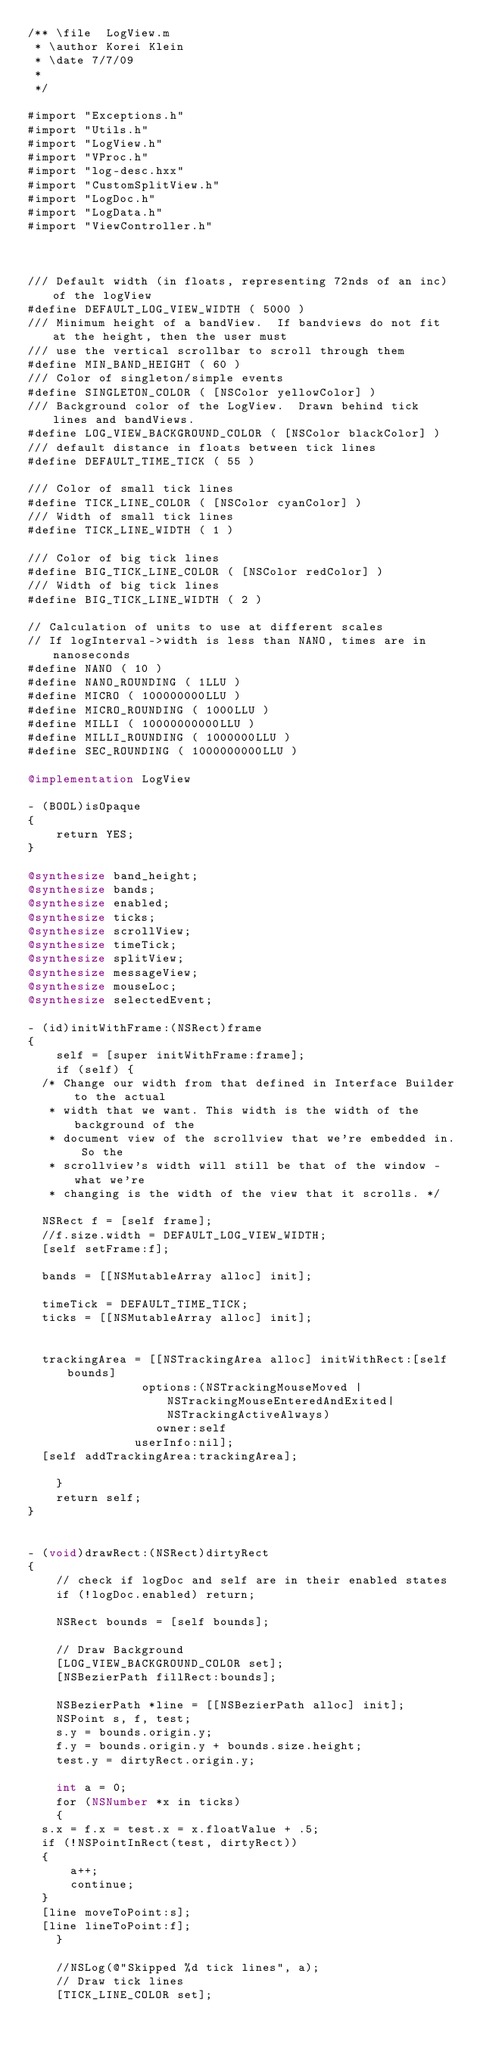Convert code to text. <code><loc_0><loc_0><loc_500><loc_500><_ObjectiveC_>/** \file  LogView.m
 * \author Korei Klein
 * \date 7/7/09
 *
 */

#import "Exceptions.h"
#import "Utils.h"
#import "LogView.h"
#import "VProc.h"
#import "log-desc.hxx"
#import "CustomSplitView.h"
#import "LogDoc.h"
#import "LogData.h"
#import "ViewController.h"



/// Default width (in floats, representing 72nds of an inc) of the logView
#define DEFAULT_LOG_VIEW_WIDTH ( 5000 )
/// Minimum height of a bandView.  If bandviews do not fit at the height, then the user must
/// use the vertical scrollbar to scroll through them
#define MIN_BAND_HEIGHT ( 60 )
/// Color of singleton/simple events
#define SINGLETON_COLOR ( [NSColor yellowColor] )
/// Background color of the LogView.  Drawn behind tick lines and bandViews.
#define LOG_VIEW_BACKGROUND_COLOR ( [NSColor blackColor] )
/// default distance in floats between tick lines
#define DEFAULT_TIME_TICK ( 55 )

/// Color of small tick lines
#define TICK_LINE_COLOR ( [NSColor cyanColor] )
/// Width of small tick lines
#define TICK_LINE_WIDTH ( 1 )

/// Color of big tick lines
#define BIG_TICK_LINE_COLOR ( [NSColor redColor] )
/// Width of big tick lines
#define BIG_TICK_LINE_WIDTH ( 2 )

// Calculation of units to use at different scales
// If logInterval->width is less than NANO, times are in nanoseconds
#define NANO ( 10 )
#define NANO_ROUNDING ( 1LLU )
#define MICRO ( 100000000LLU )
#define MICRO_ROUNDING ( 1000LLU )
#define MILLI ( 10000000000LLU )
#define MILLI_ROUNDING ( 1000000LLU )
#define SEC_ROUNDING ( 1000000000LLU )

@implementation LogView

- (BOOL)isOpaque
{
    return YES;
}

@synthesize band_height;
@synthesize bands;
@synthesize enabled;
@synthesize ticks;
@synthesize scrollView;
@synthesize timeTick;
@synthesize splitView;
@synthesize messageView;
@synthesize mouseLoc;
@synthesize selectedEvent;

- (id)initWithFrame:(NSRect)frame
{
    self = [super initWithFrame:frame];
    if (self) {
	/* Change our width from that defined in Interface Builder to the actual
	 * width that we want. This width is the width of the background of the
	 * document view of the scrollview that we're embedded in. So the
	 * scrollview's width will still be that of the window - what we're
	 * changing is the width of the view that it scrolls. */
	
	NSRect f = [self frame];
	//f.size.width = DEFAULT_LOG_VIEW_WIDTH;
	[self setFrame:f];
	
	bands = [[NSMutableArray alloc] init];
	
	timeTick = DEFAULT_TIME_TICK;
	ticks = [[NSMutableArray alloc] init];

	
	trackingArea = [[NSTrackingArea alloc] initWithRect:[self bounds]
						    options:(NSTrackingMouseMoved | NSTrackingMouseEnteredAndExited| NSTrackingActiveAlways)
						      owner:self
						   userInfo:nil];
	[self addTrackingArea:trackingArea];

    }
    return self;
}


- (void)drawRect:(NSRect)dirtyRect
{
    // check if logDoc and self are in their enabled states
    if (!logDoc.enabled) return;
    
    NSRect bounds = [self bounds];

    // Draw Background
    [LOG_VIEW_BACKGROUND_COLOR set];
    [NSBezierPath fillRect:bounds];
    
    NSBezierPath *line = [[NSBezierPath alloc] init];
    NSPoint s, f, test;
    s.y = bounds.origin.y;
    f.y = bounds.origin.y + bounds.size.height;
    test.y = dirtyRect.origin.y;

    int a = 0;
    for (NSNumber *x in ticks)
    {
	s.x = f.x = test.x = x.floatValue + .5;
	if (!NSPointInRect(test, dirtyRect))
	{
	    a++;
	    continue;
	}
	[line moveToPoint:s];
	[line lineToPoint:f];
    }

    //NSLog(@"Skipped %d tick lines", a);
    // Draw tick lines
    [TICK_LINE_COLOR set];</code> 